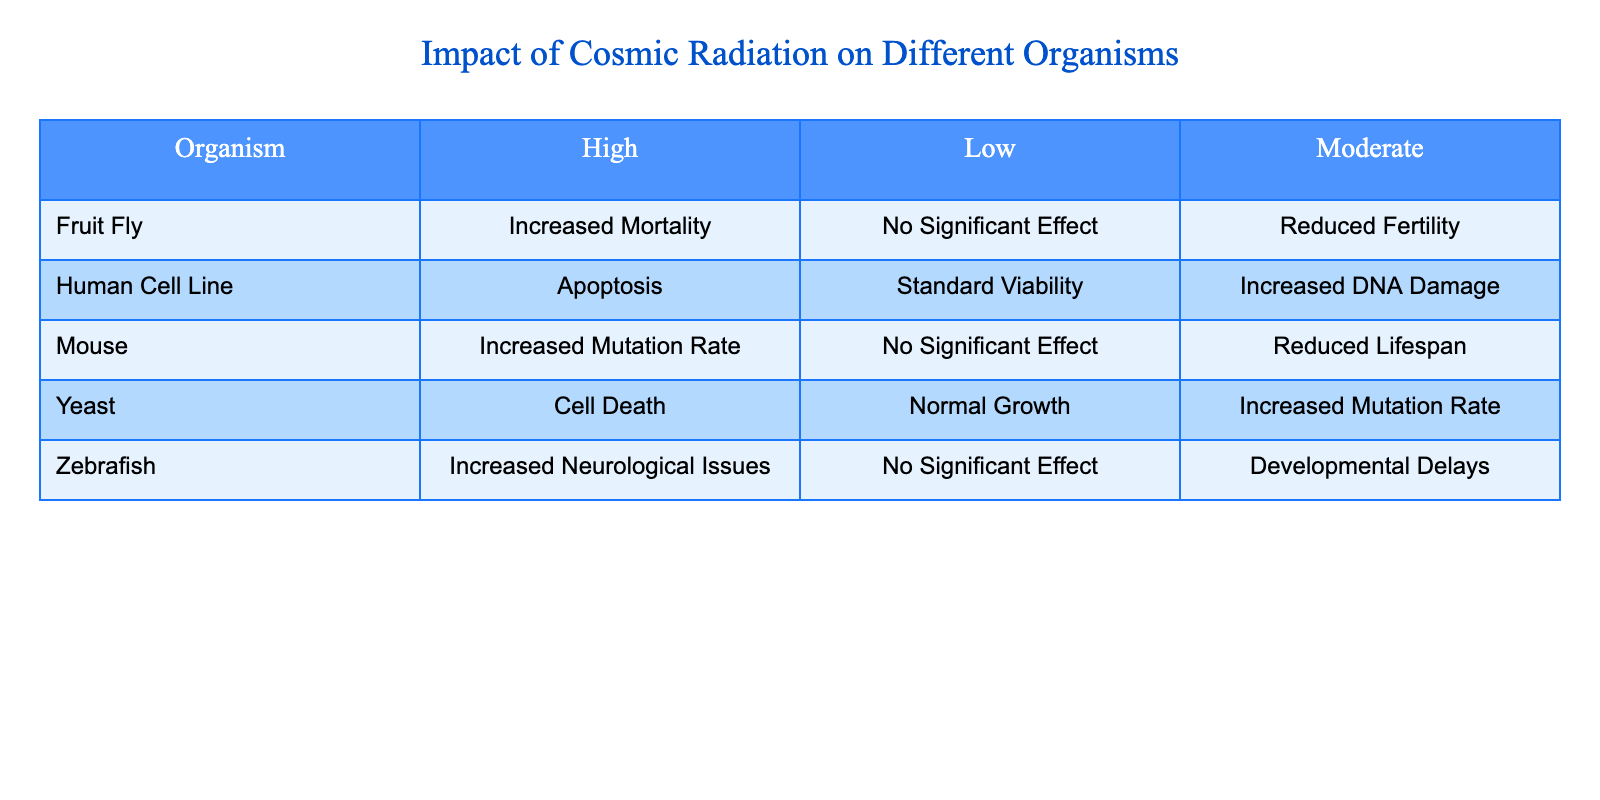Which organism has the highest reported effect from high cosmic radiation exposure? From the table, under the "High" exposure level, we see that the "Human Cell Line" experiences "Apoptosis," while the "Yeast" reports "Cell Death," and "Fruit Fly" reports "Increased Mortality." However, "Mouse" shows "Increased Mutation Rate." The term "Apoptosis" indicates a more severe consequence for human cells compared to others, so it is the most severe effect listed for high exposure.
Answer: Human Cell Line What effect does moderate cosmic radiation exposure have on zebrafish? Referring to the table, the effect listed for zebrafish under "Moderate" cosmic radiation exposure is "Developmental Delays." This information is directly accessible in the table without requiring further calculations or inferences.
Answer: Developmental Delays Do mice show any significant effect under low radiation exposure? By reviewing the table, it can be seen that under "Low" radiation exposure, the effect on mice is "No Significant Effect." This is a straightforward retrieval of information from the table.
Answer: No How many organisms experience increased mutation rates, and what are they? The table shows two organisms with increased mutation rates: "Mouse" (under "High") and "Yeast" (under "Moderate"). Counting these, we find there are two organisms that report such an outcome. The question involves combining information from different rows in the table.
Answer: Two: Mouse and Yeast Is there a difference in the effects of cosmic radiation exposure on fruit flies between moderate and high levels? Yes, in the table, under "Moderate," the effect on fruit flies is "Reduced Fertility," while under "High," the effect is "Increased Mortality." Therefore, these effects differ, as one is a reproductive effect and the other relates to survival. This involves analyzing different exposures for the same organism.
Answer: Yes 